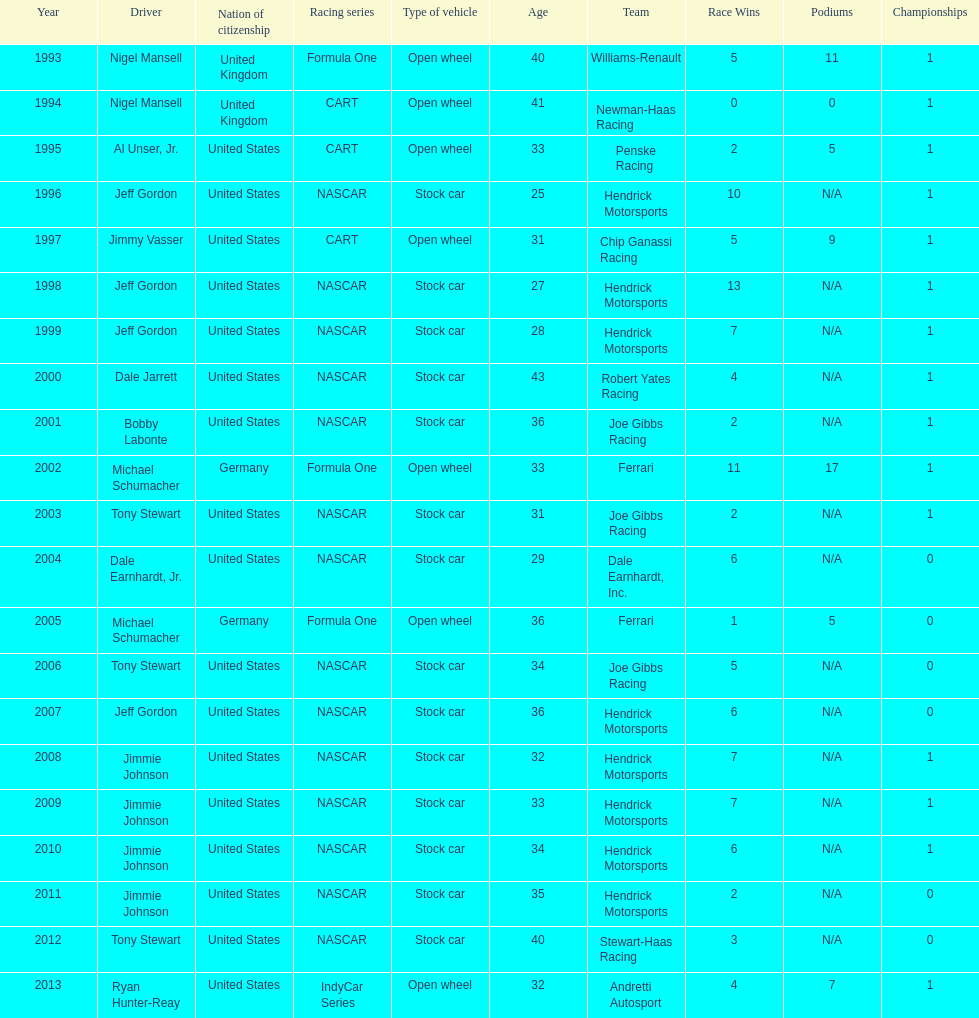How many total row entries are there? 21. 